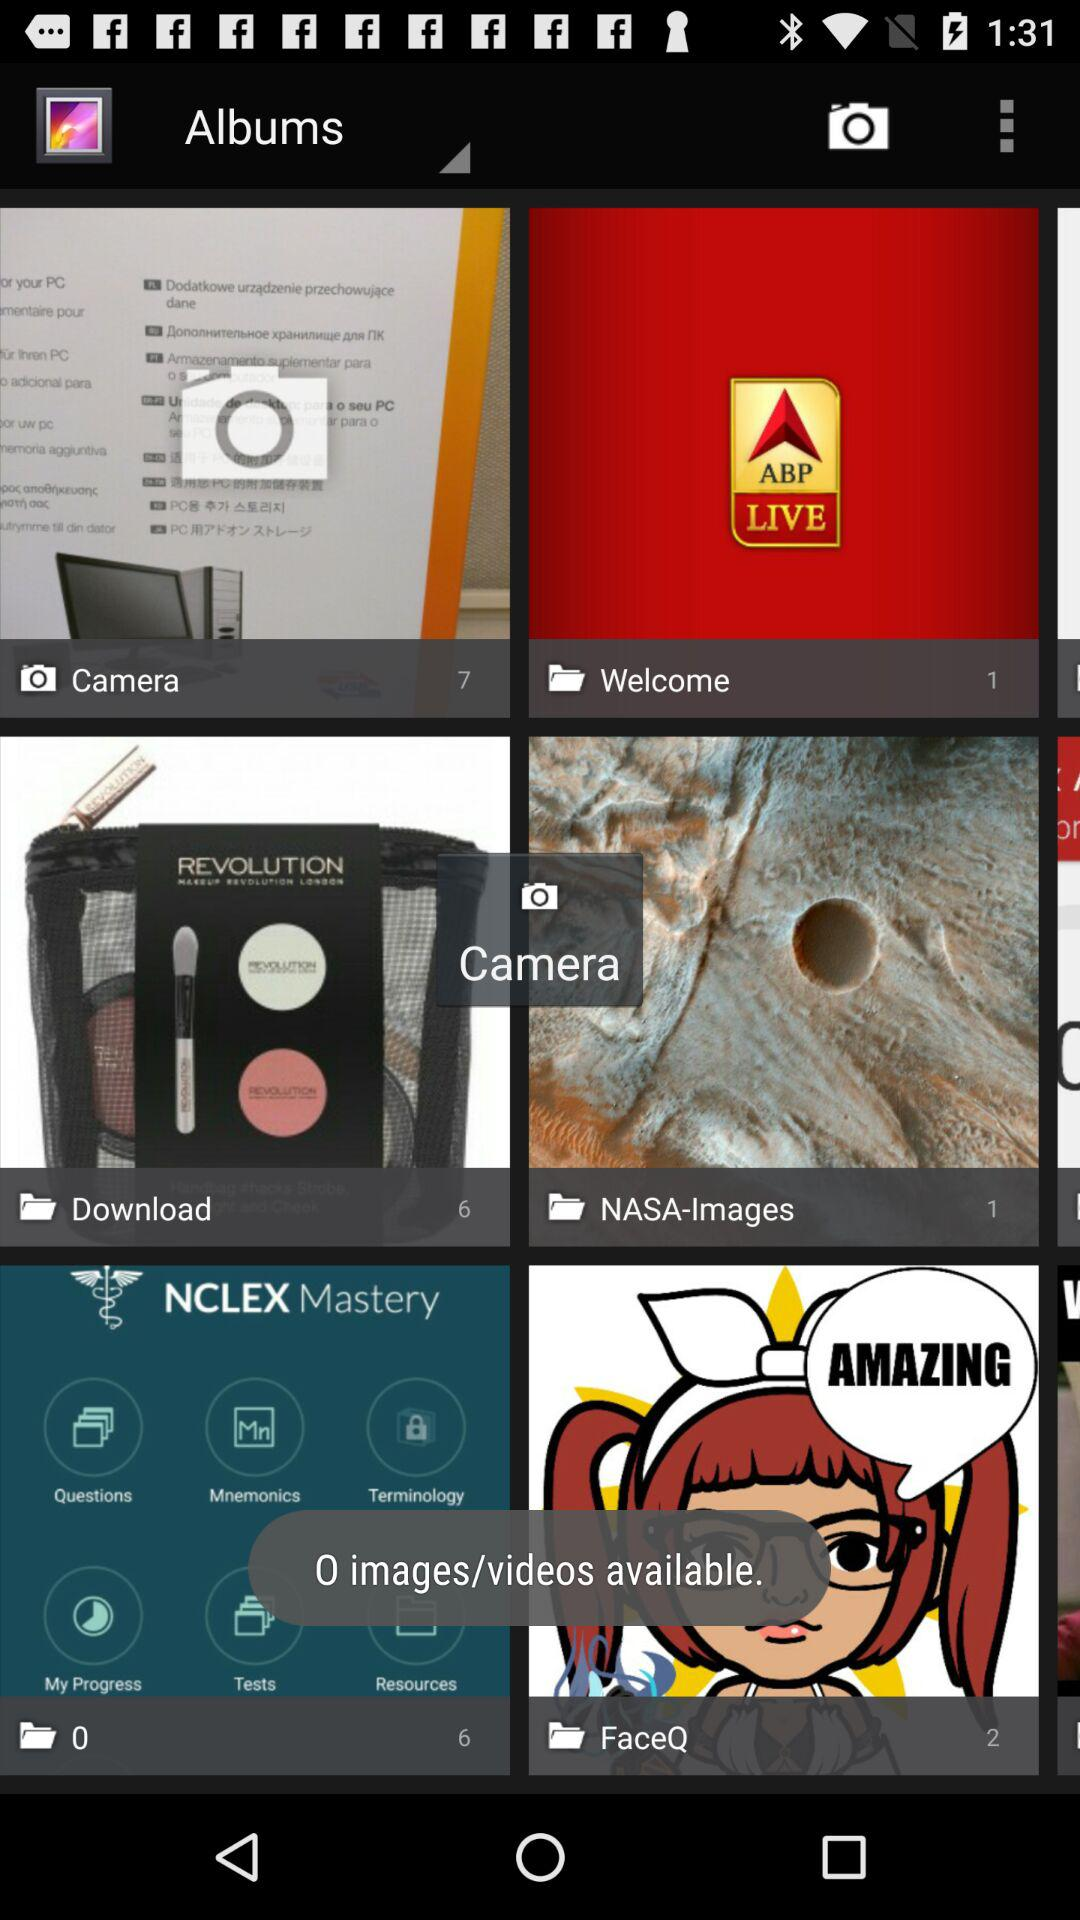How many images are in the download folder? There are 6 images in the download folder. 